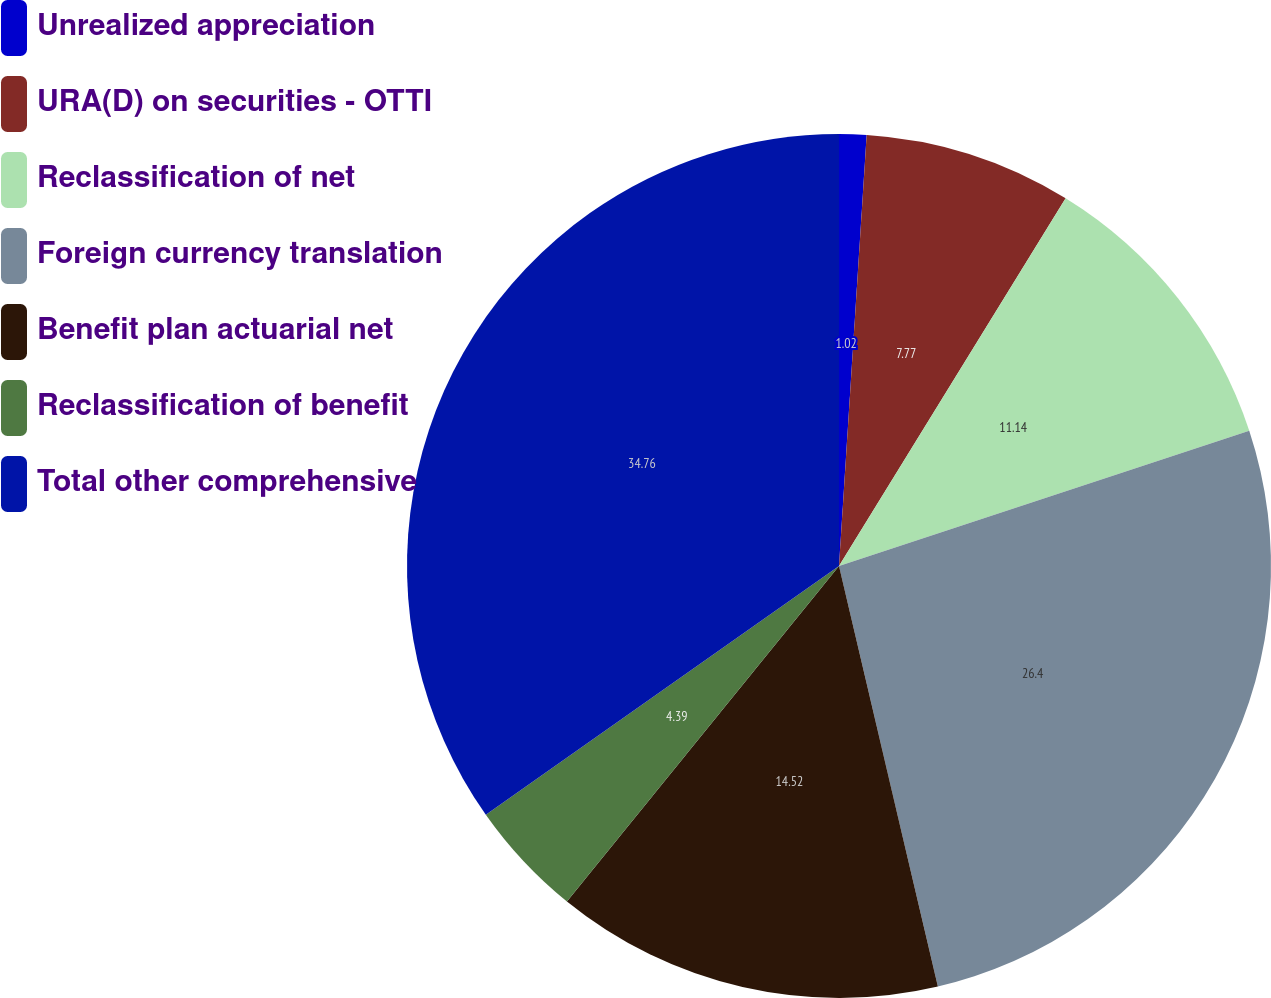Convert chart to OTSL. <chart><loc_0><loc_0><loc_500><loc_500><pie_chart><fcel>Unrealized appreciation<fcel>URA(D) on securities - OTTI<fcel>Reclassification of net<fcel>Foreign currency translation<fcel>Benefit plan actuarial net<fcel>Reclassification of benefit<fcel>Total other comprehensive<nl><fcel>1.02%<fcel>7.77%<fcel>11.14%<fcel>26.4%<fcel>14.52%<fcel>4.39%<fcel>34.77%<nl></chart> 